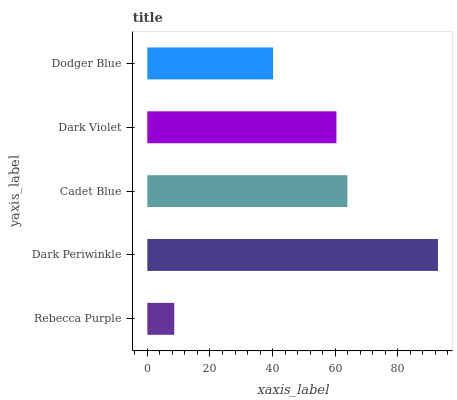Is Rebecca Purple the minimum?
Answer yes or no. Yes. Is Dark Periwinkle the maximum?
Answer yes or no. Yes. Is Cadet Blue the minimum?
Answer yes or no. No. Is Cadet Blue the maximum?
Answer yes or no. No. Is Dark Periwinkle greater than Cadet Blue?
Answer yes or no. Yes. Is Cadet Blue less than Dark Periwinkle?
Answer yes or no. Yes. Is Cadet Blue greater than Dark Periwinkle?
Answer yes or no. No. Is Dark Periwinkle less than Cadet Blue?
Answer yes or no. No. Is Dark Violet the high median?
Answer yes or no. Yes. Is Dark Violet the low median?
Answer yes or no. Yes. Is Dodger Blue the high median?
Answer yes or no. No. Is Dark Periwinkle the low median?
Answer yes or no. No. 